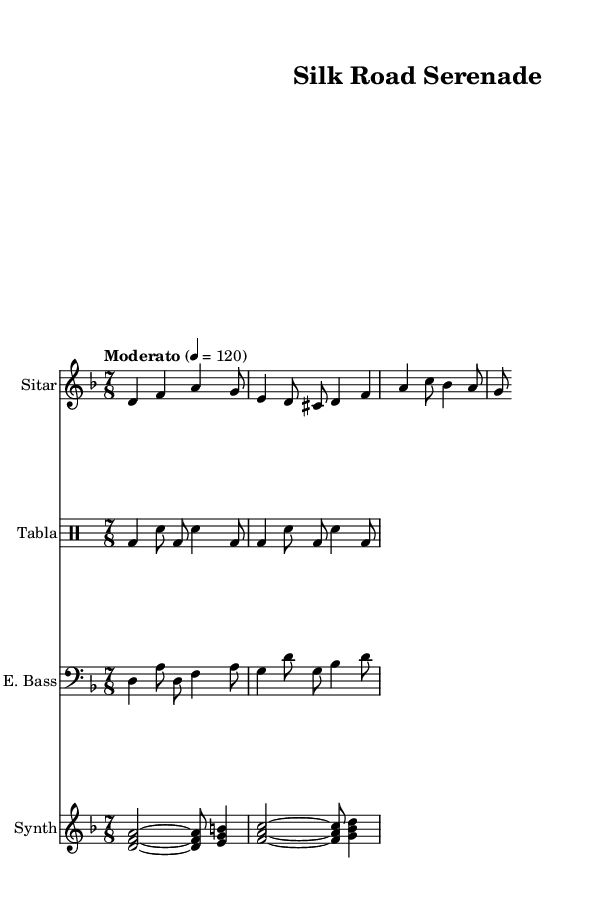What is the key signature of this music? The key signature is indicated at the beginning of the piece, showing two flats (B flat and E flat), which corresponds to D minor.
Answer: D minor What is the time signature used in this piece? The time signature is presented as a fraction at the beginning of the score, which is 7/8. This means there are seven beats in a measure and the eighth note gets the beat.
Answer: 7/8 What tempo marking is indicated for this composition? The tempo marking is typically noted just above the musical staff, and it states "Moderato" with a metronome marking of 120 beats per minute.
Answer: Moderato 120 How many measures are there in the sitar part? By counting the group of notes and dividing them into individual sections based on bar lines, we can see that there are 3 measures in total in the provided sitar part.
Answer: 3 measures Which instrument has a bass clef? The instrument staff is explicitly labeled, and examining the clefs, the electric bass staff shows the bass clef symbol, indicating it is an instrument for lower-pitched notes.
Answer: Electric Bass What rhythmic pattern does the tabla follow? The tabla part can be observed for its distinct rhythmic structure, which features a repeating pattern of beats and sides indicated in the notation, showcasing a regular alternating beat cycle.
Answer: Alternating beats What kind of fusion does this piece represent? Observing the combination of musical instruments and styles, one can deduce it blends traditional Indian instrumentation (sitar and tabla) with modern elements (electric bass and synth), resulting in a fusion genre.
Answer: East-West fusion 